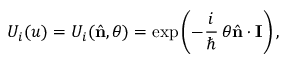Convert formula to latex. <formula><loc_0><loc_0><loc_500><loc_500>U _ { i } ( u ) = U _ { i } ( { \hat { n } } , \theta ) = \exp \left ( - \frac { i } { } \, \theta { \hat { n } } \cdot { I } \right ) ,</formula> 